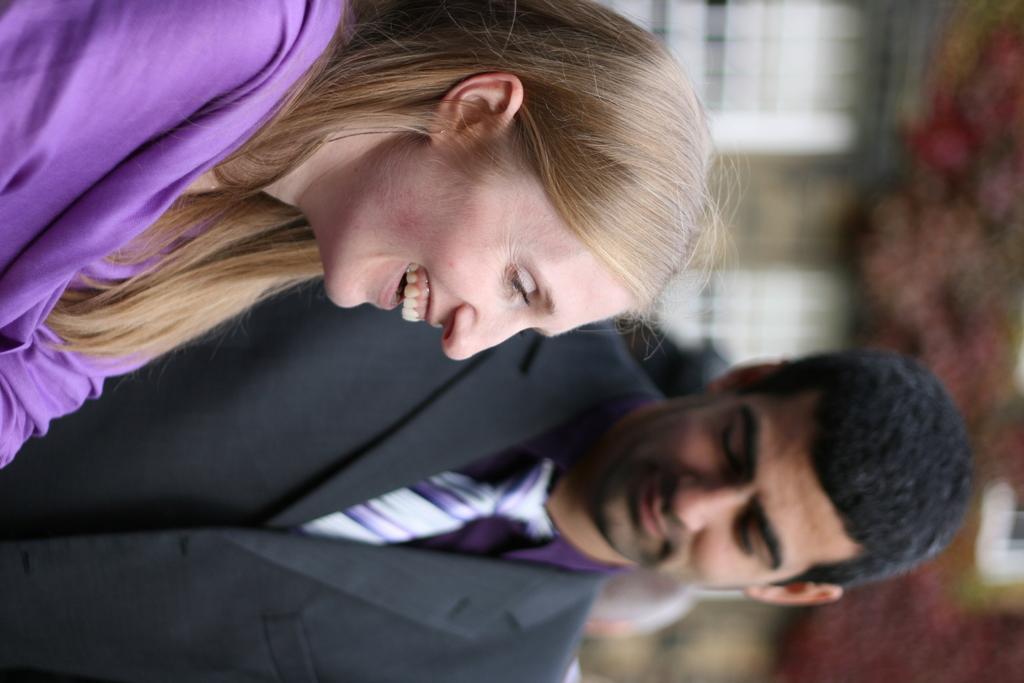Please provide a concise description of this image. This image is taken outdoors. On the right side of the image there is a building and there are a few trees. On the left side of the image there is a man and there is a woman and they are with smiling faces. 